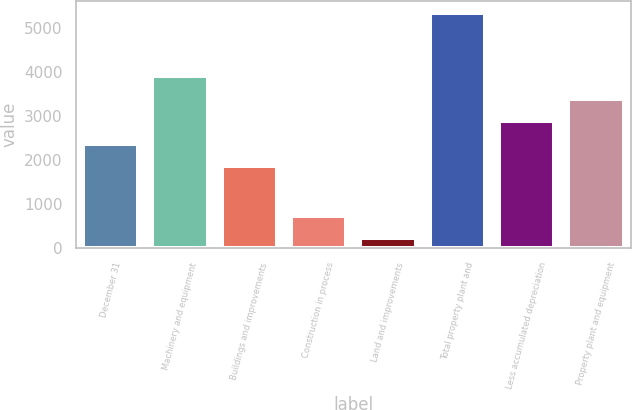<chart> <loc_0><loc_0><loc_500><loc_500><bar_chart><fcel>December 31<fcel>Machinery and equipment<fcel>Buildings and improvements<fcel>Construction in process<fcel>Land and improvements<fcel>Total property plant and<fcel>Less accumulated depreciation<fcel>Property plant and equipment<nl><fcel>2374.3<fcel>3908.2<fcel>1863<fcel>738.3<fcel>227<fcel>5340<fcel>2885.6<fcel>3396.9<nl></chart> 